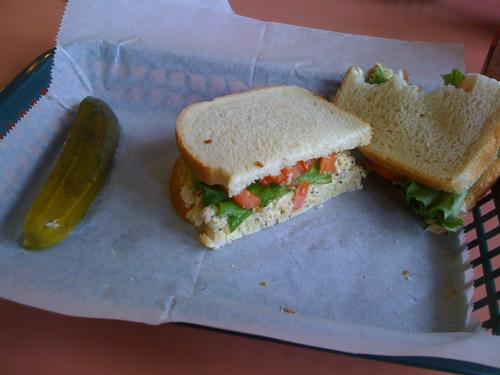Mention the location of the food and the container holding it. The food is placed on white wax paper in a blue basket with square holes, sitting on a peachy colored table. Highlight the colors and features of the table where the food is placed. The food is placed on a peachy-colored table and the black tray is resting on a brown tabletop with crumbs scattered. Mention the distinctive features of the tray holding the food. The black tray with square holes holds the food, which is placed on white wax paper and consists of a sandwich and a pickle. Describe the state of the sandwich in relation to the other items in the scene. A bitten-off tuna salad sandwich is placed on wax paper next to a whole, green pickle, surrounded by crumbs on a peachy-table. Describe the surroundings and the food items in the image. The tuna salad sandwich with lettuce and tomatoes sits on white wax paper, next to a green pickle, on a peachy table with crumbs. Provide a brief overview of the primary components of the image. A tuna salad sandwich with lettuce and tomatoes on white bread is placed on wax paper, accompanied by a whole green pickle, in a black tray with square holes. Describe the condition of the sandwich and its contents in the image. The sandwich is made of white bread and has been bitten off, revealing layers of tuna salad, lettuce, and tomatoes inside. Write about the sandwich's bread and the condition it is in. The sandwich, bitten off, is made of white bread with crusty edges and reveals its tuna salad, lettuce, and tomato filling. Detail the appearance and characteristics of the tray holding the food. The food is placed in a black tray with square holes in it, that is resting on a peachy-colored tabletop. List the primary items included in the image's scene. Tuna salad sandwich, whole pickle, wax paper, blue tray, lettuce, tomatoes, crumbs, peachy-colored table. 